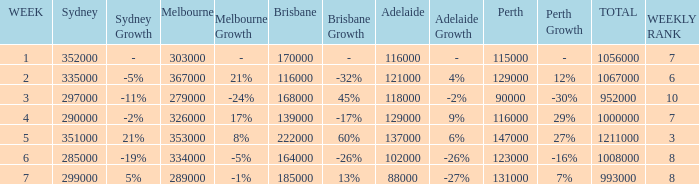How many viewers were there in Sydney for the episode when there were 334000 in Melbourne? 285000.0. 